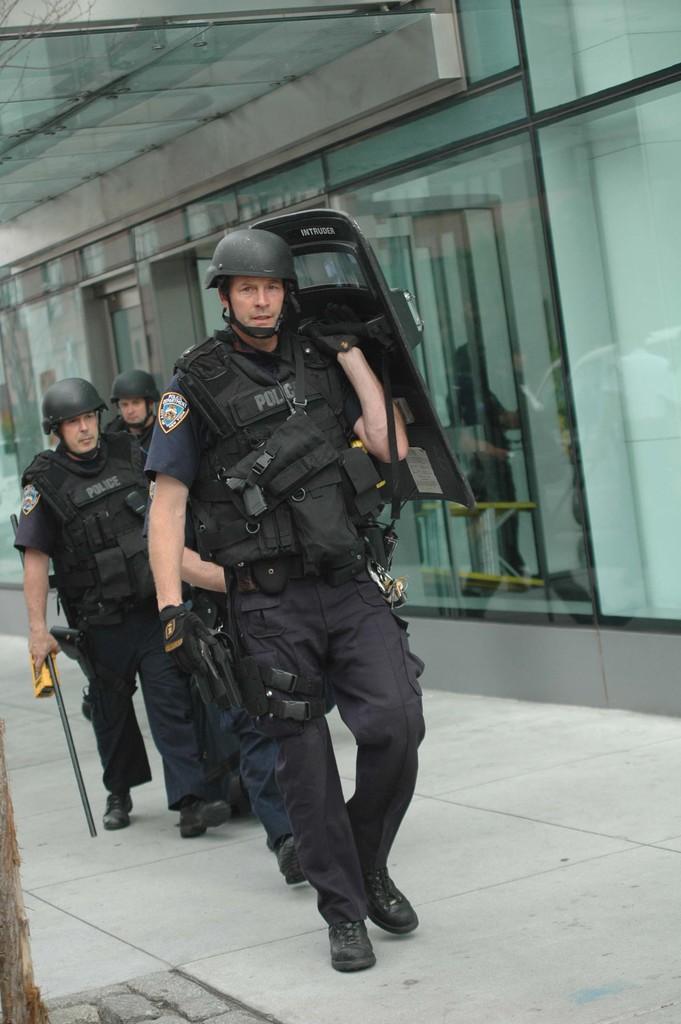In one or two sentences, can you explain what this image depicts? In this image we can see the policeman holding some objects and walking on the path. In the background we can see the buildings with the glass windows. In the bottom left corner we can see the bark of a tree. 